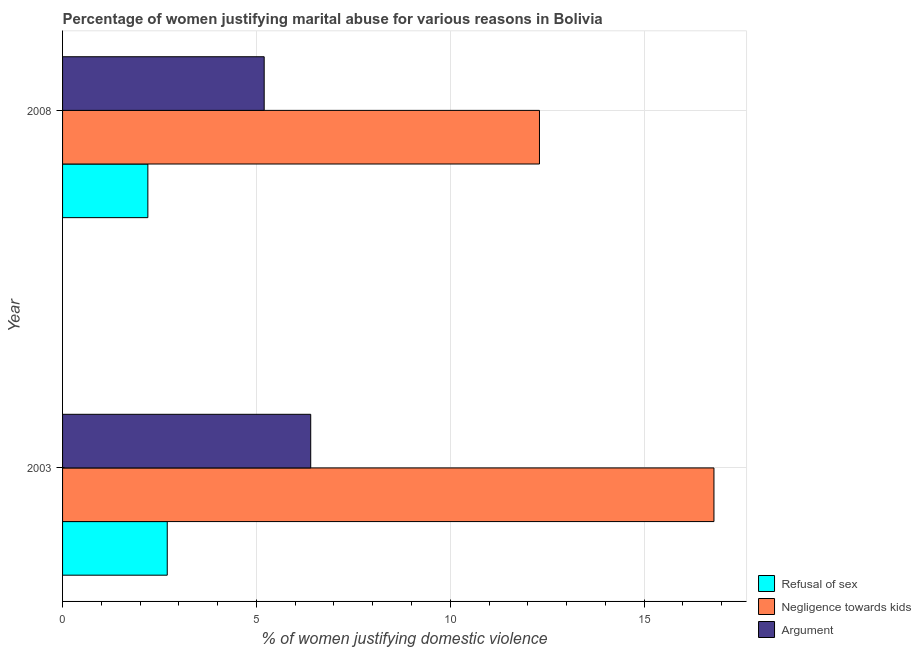How many different coloured bars are there?
Your answer should be compact. 3. How many groups of bars are there?
Keep it short and to the point. 2. Are the number of bars on each tick of the Y-axis equal?
Provide a succinct answer. Yes. How many bars are there on the 2nd tick from the bottom?
Offer a terse response. 3. What is the label of the 2nd group of bars from the top?
Keep it short and to the point. 2003. Across all years, what is the minimum percentage of women justifying domestic violence due to arguments?
Provide a succinct answer. 5.2. In which year was the percentage of women justifying domestic violence due to refusal of sex maximum?
Your answer should be compact. 2003. What is the total percentage of women justifying domestic violence due to negligence towards kids in the graph?
Keep it short and to the point. 29.1. What is the difference between the percentage of women justifying domestic violence due to negligence towards kids in 2008 and the percentage of women justifying domestic violence due to arguments in 2003?
Provide a succinct answer. 5.9. What is the average percentage of women justifying domestic violence due to refusal of sex per year?
Make the answer very short. 2.45. In the year 2008, what is the difference between the percentage of women justifying domestic violence due to refusal of sex and percentage of women justifying domestic violence due to arguments?
Provide a succinct answer. -3. What is the ratio of the percentage of women justifying domestic violence due to negligence towards kids in 2003 to that in 2008?
Your answer should be compact. 1.37. What does the 3rd bar from the top in 2008 represents?
Offer a very short reply. Refusal of sex. What does the 2nd bar from the bottom in 2008 represents?
Make the answer very short. Negligence towards kids. How many bars are there?
Keep it short and to the point. 6. How many years are there in the graph?
Make the answer very short. 2. What is the difference between two consecutive major ticks on the X-axis?
Make the answer very short. 5. Where does the legend appear in the graph?
Offer a terse response. Bottom right. How many legend labels are there?
Offer a terse response. 3. What is the title of the graph?
Ensure brevity in your answer.  Percentage of women justifying marital abuse for various reasons in Bolivia. What is the label or title of the X-axis?
Give a very brief answer. % of women justifying domestic violence. What is the label or title of the Y-axis?
Your response must be concise. Year. What is the % of women justifying domestic violence in Refusal of sex in 2003?
Make the answer very short. 2.7. What is the % of women justifying domestic violence of Refusal of sex in 2008?
Your answer should be compact. 2.2. What is the % of women justifying domestic violence of Argument in 2008?
Your answer should be very brief. 5.2. Across all years, what is the minimum % of women justifying domestic violence in Negligence towards kids?
Provide a succinct answer. 12.3. What is the total % of women justifying domestic violence of Negligence towards kids in the graph?
Your response must be concise. 29.1. What is the difference between the % of women justifying domestic violence in Refusal of sex in 2003 and that in 2008?
Give a very brief answer. 0.5. What is the difference between the % of women justifying domestic violence in Negligence towards kids in 2003 and that in 2008?
Your answer should be compact. 4.5. What is the difference between the % of women justifying domestic violence of Argument in 2003 and that in 2008?
Provide a succinct answer. 1.2. What is the difference between the % of women justifying domestic violence in Refusal of sex in 2003 and the % of women justifying domestic violence in Argument in 2008?
Your response must be concise. -2.5. What is the average % of women justifying domestic violence in Refusal of sex per year?
Your answer should be very brief. 2.45. What is the average % of women justifying domestic violence of Negligence towards kids per year?
Provide a succinct answer. 14.55. In the year 2003, what is the difference between the % of women justifying domestic violence in Refusal of sex and % of women justifying domestic violence in Negligence towards kids?
Your answer should be very brief. -14.1. In the year 2008, what is the difference between the % of women justifying domestic violence in Negligence towards kids and % of women justifying domestic violence in Argument?
Your answer should be very brief. 7.1. What is the ratio of the % of women justifying domestic violence in Refusal of sex in 2003 to that in 2008?
Provide a succinct answer. 1.23. What is the ratio of the % of women justifying domestic violence in Negligence towards kids in 2003 to that in 2008?
Offer a very short reply. 1.37. What is the ratio of the % of women justifying domestic violence of Argument in 2003 to that in 2008?
Provide a short and direct response. 1.23. What is the difference between the highest and the second highest % of women justifying domestic violence of Negligence towards kids?
Your answer should be compact. 4.5. What is the difference between the highest and the second highest % of women justifying domestic violence of Argument?
Make the answer very short. 1.2. 